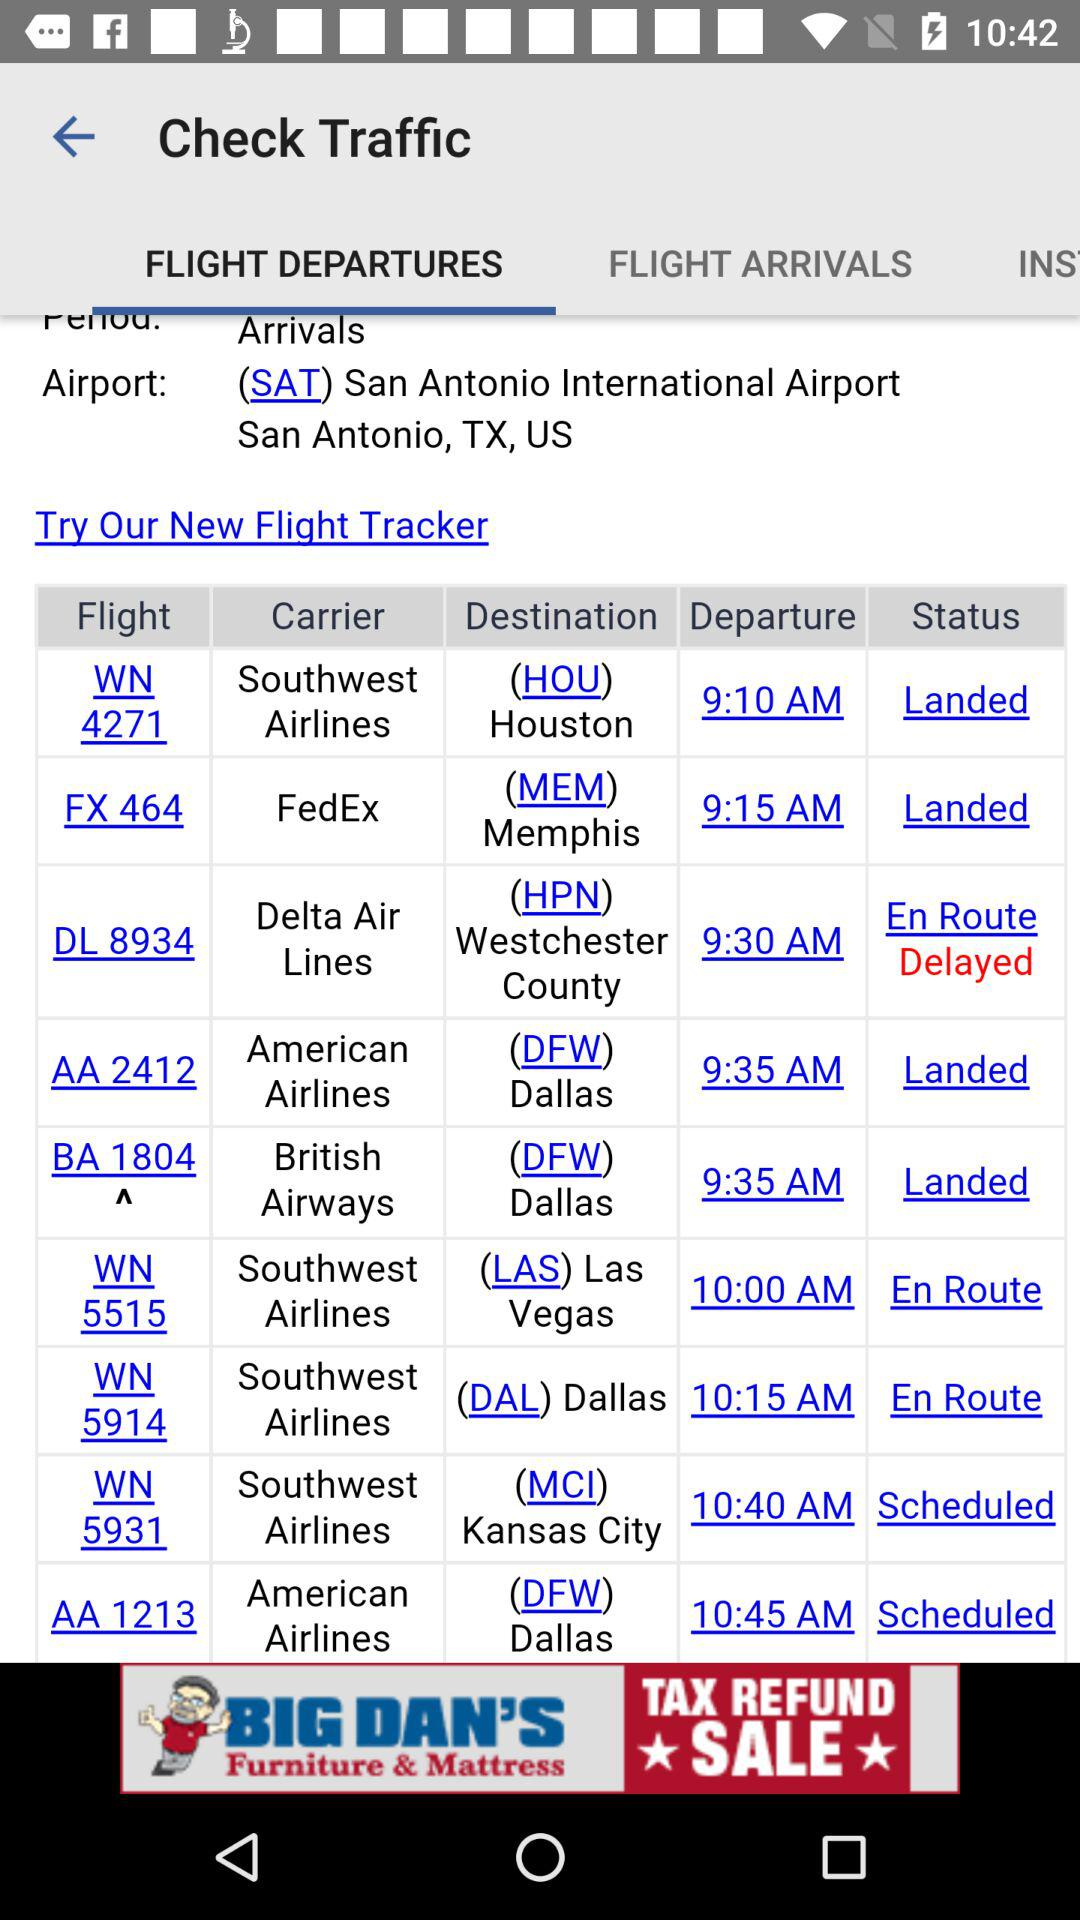How many flights are delayed?
Answer the question using a single word or phrase. 1 